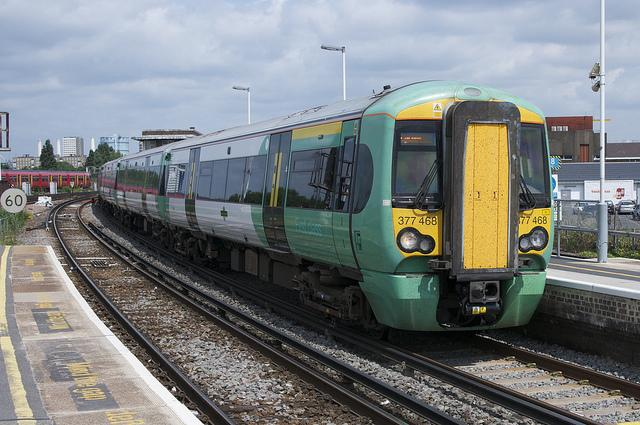What are the black poles on the front train window? Please explain your reasoning. wipers. The poles are wipers. 